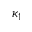Convert formula to latex. <formula><loc_0><loc_0><loc_500><loc_500>\kappa _ { 1 }</formula> 